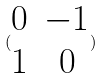<formula> <loc_0><loc_0><loc_500><loc_500>( \begin{matrix} 0 & - 1 \\ 1 & 0 \end{matrix} )</formula> 